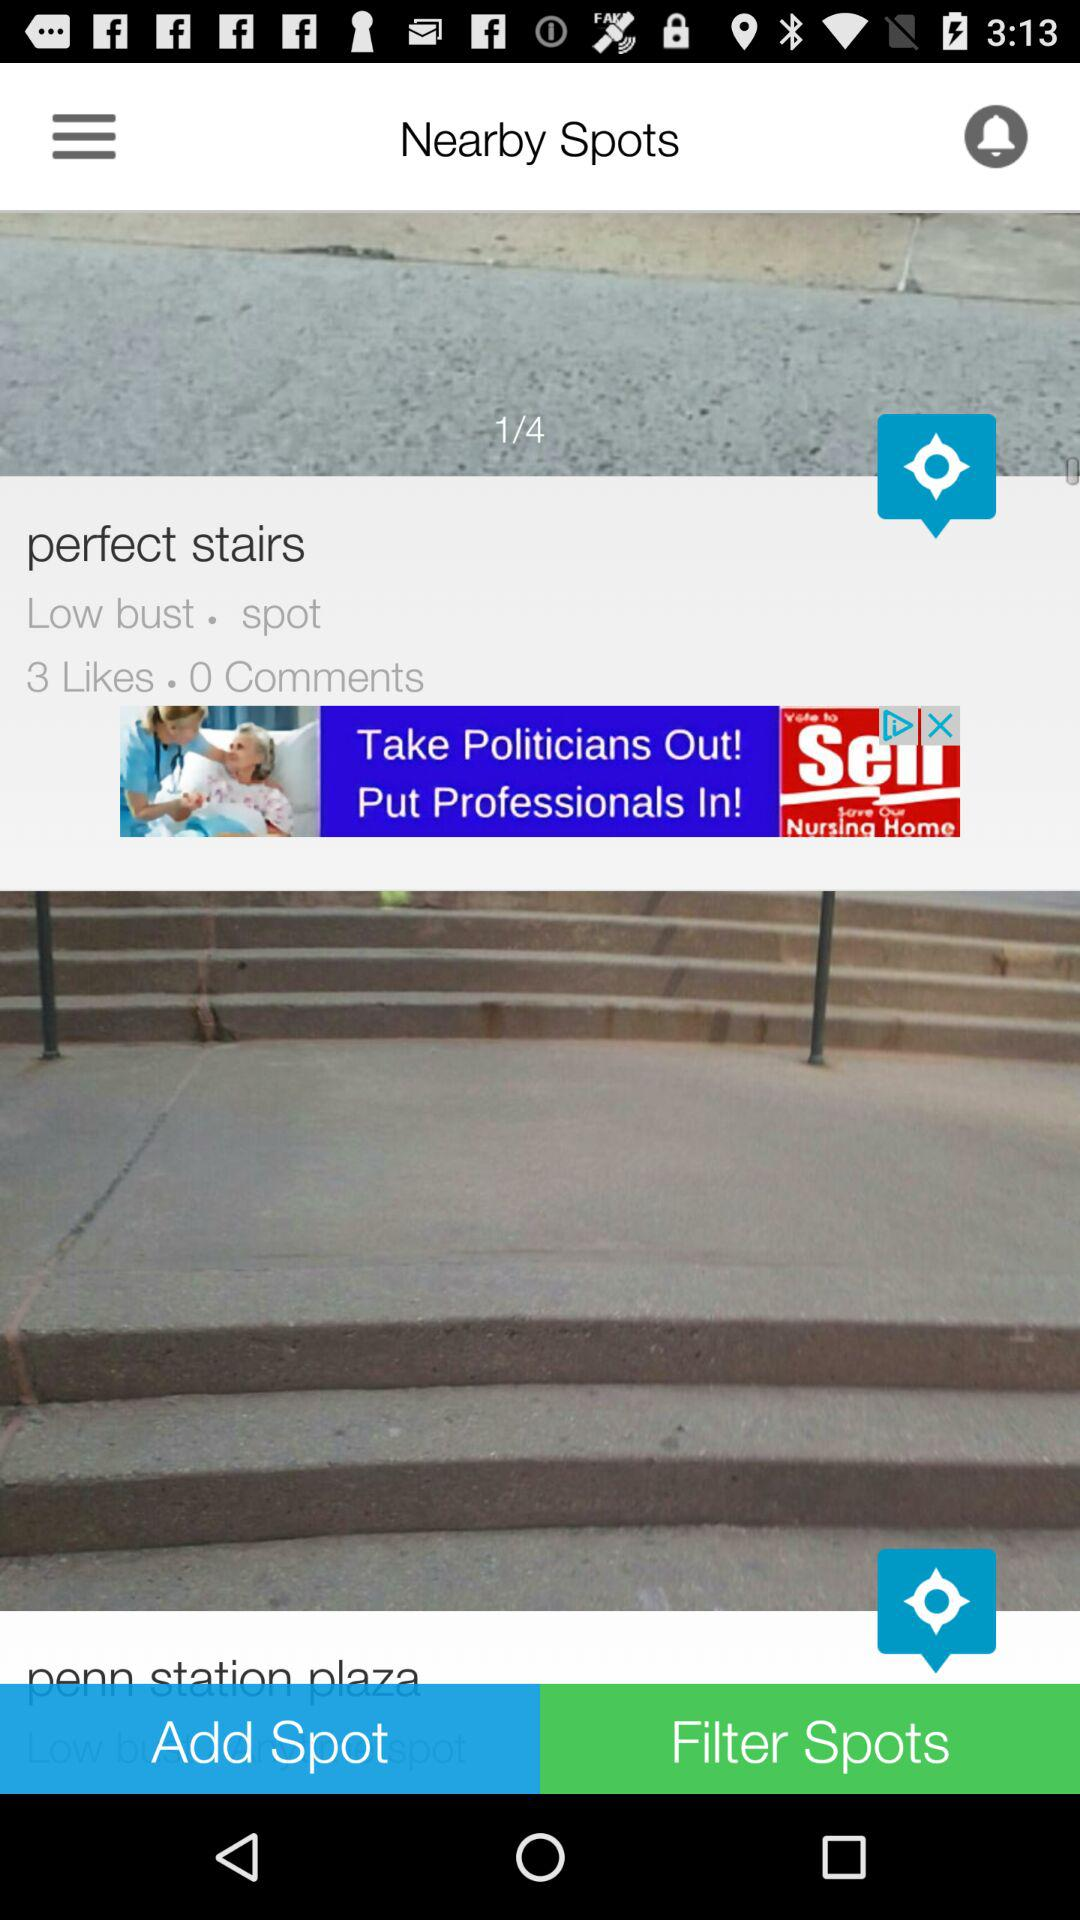How many comments does the spot with the text 'perfect stairs' have?
Answer the question using a single word or phrase. 0 